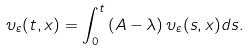<formula> <loc_0><loc_0><loc_500><loc_500>\upsilon _ { \varepsilon } ( t , x ) = \int _ { 0 } ^ { t } \left ( A - \lambda \right ) \upsilon _ { \varepsilon } ( s , x ) d s .</formula> 